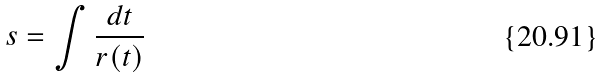Convert formula to latex. <formula><loc_0><loc_0><loc_500><loc_500>s = \int \frac { d t } { r ( t ) }</formula> 